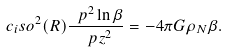Convert formula to latex. <formula><loc_0><loc_0><loc_500><loc_500>c _ { i } s o ^ { 2 } ( R ) \frac { \ p ^ { 2 } \ln { \beta } } { \ p z ^ { 2 } } = - 4 \pi G \rho _ { N } \beta .</formula> 